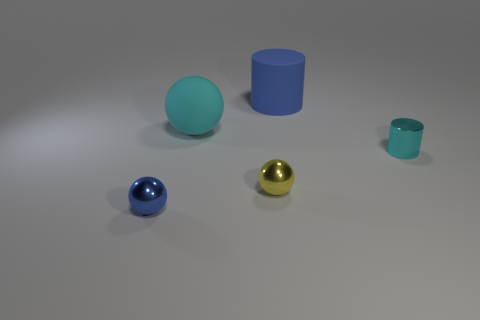Subtract all cyan spheres. How many spheres are left? 2 Subtract all yellow spheres. How many spheres are left? 2 Add 4 big green matte cubes. How many objects exist? 9 Subtract all cylinders. How many objects are left? 3 Subtract all purple balls. How many cyan cylinders are left? 1 Subtract 0 cyan blocks. How many objects are left? 5 Subtract 2 cylinders. How many cylinders are left? 0 Subtract all brown spheres. Subtract all yellow cylinders. How many spheres are left? 3 Subtract all tiny gray spheres. Subtract all rubber spheres. How many objects are left? 4 Add 1 metal cylinders. How many metal cylinders are left? 2 